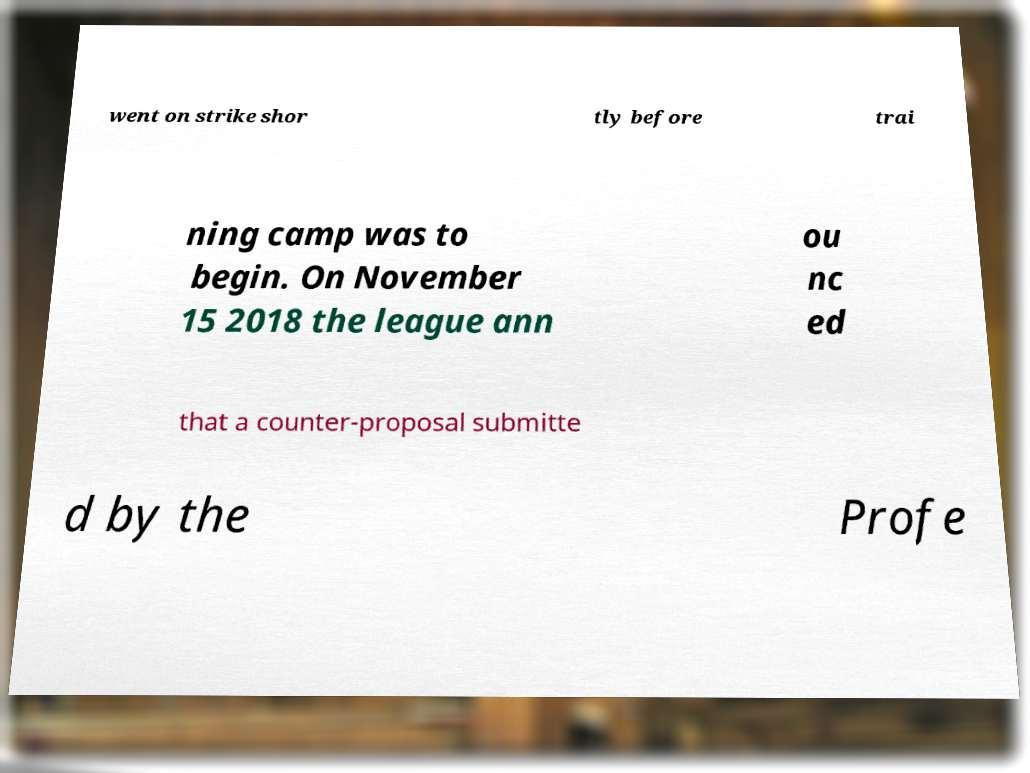What messages or text are displayed in this image? I need them in a readable, typed format. went on strike shor tly before trai ning camp was to begin. On November 15 2018 the league ann ou nc ed that a counter-proposal submitte d by the Profe 